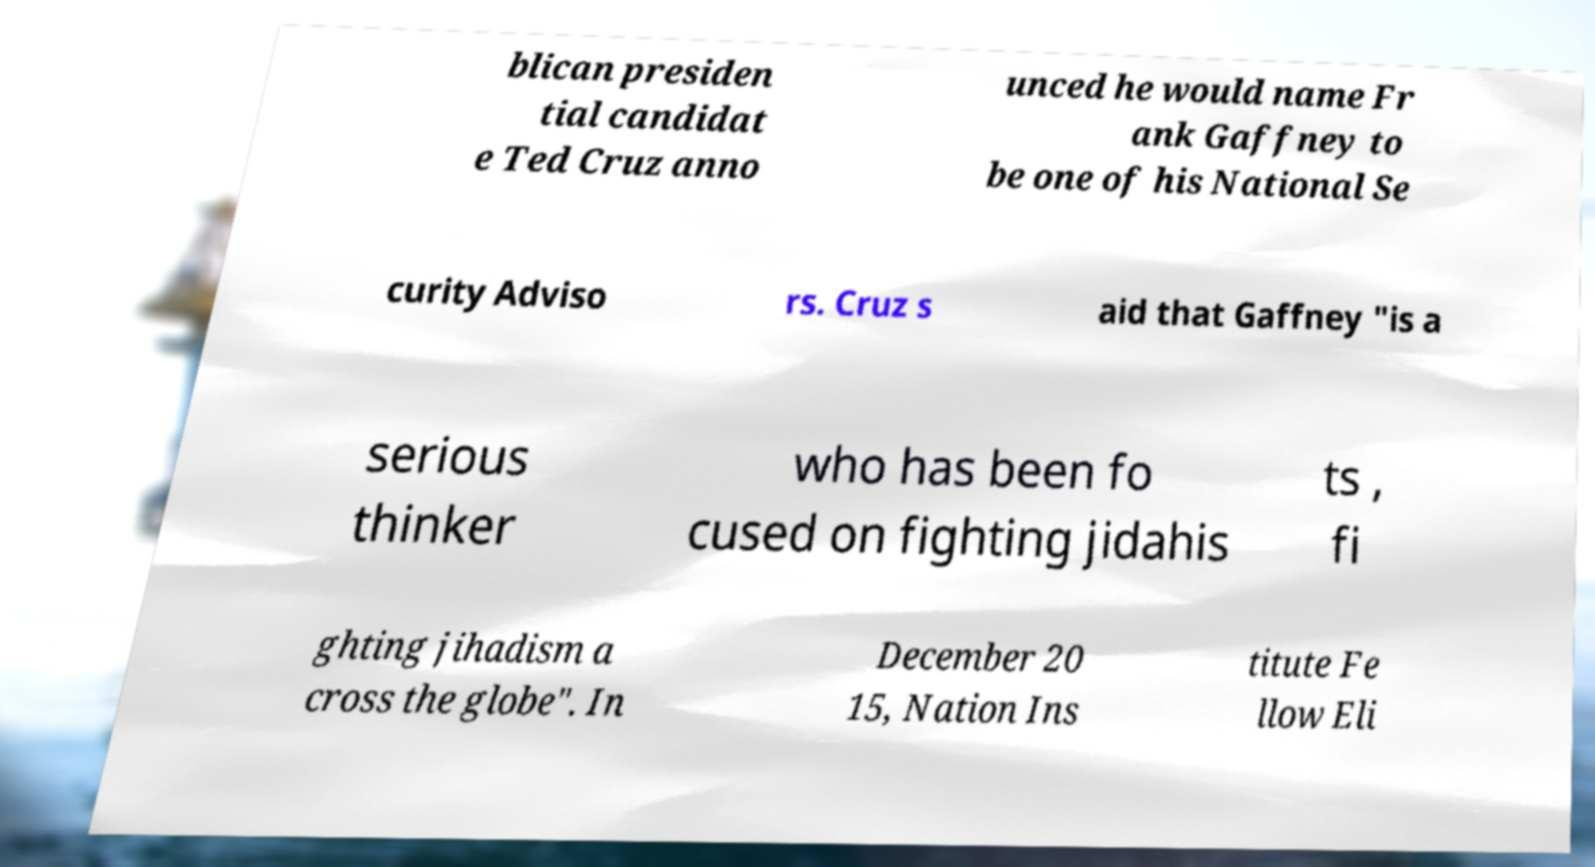There's text embedded in this image that I need extracted. Can you transcribe it verbatim? blican presiden tial candidat e Ted Cruz anno unced he would name Fr ank Gaffney to be one of his National Se curity Adviso rs. Cruz s aid that Gaffney "is a serious thinker who has been fo cused on fighting jidahis ts , fi ghting jihadism a cross the globe". In December 20 15, Nation Ins titute Fe llow Eli 